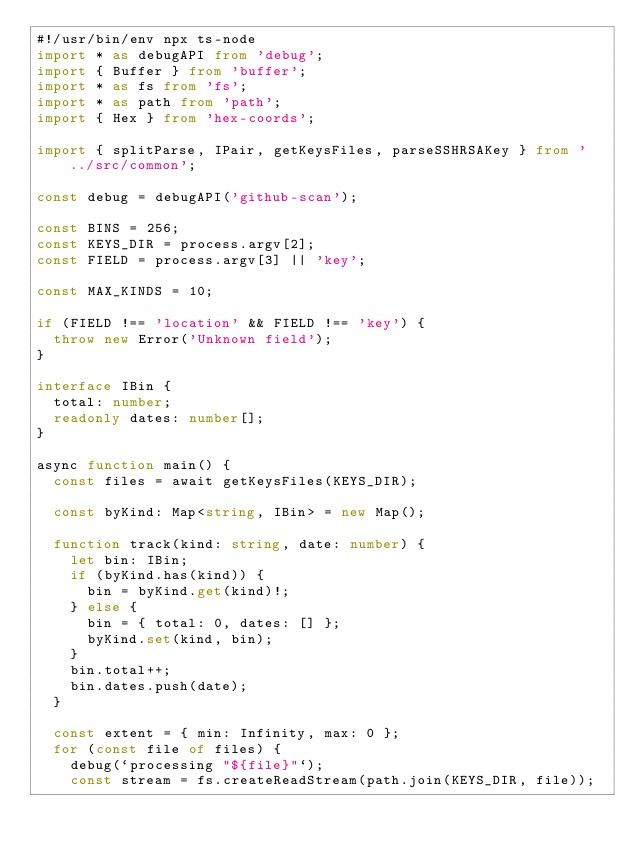Convert code to text. <code><loc_0><loc_0><loc_500><loc_500><_TypeScript_>#!/usr/bin/env npx ts-node
import * as debugAPI from 'debug';
import { Buffer } from 'buffer';
import * as fs from 'fs';
import * as path from 'path';
import { Hex } from 'hex-coords';

import { splitParse, IPair, getKeysFiles, parseSSHRSAKey } from '../src/common';

const debug = debugAPI('github-scan');

const BINS = 256;
const KEYS_DIR = process.argv[2];
const FIELD = process.argv[3] || 'key';

const MAX_KINDS = 10;

if (FIELD !== 'location' && FIELD !== 'key') {
  throw new Error('Unknown field');
}

interface IBin {
  total: number;
  readonly dates: number[];
}

async function main() {
  const files = await getKeysFiles(KEYS_DIR);

  const byKind: Map<string, IBin> = new Map();

  function track(kind: string, date: number) {
    let bin: IBin;
    if (byKind.has(kind)) {
      bin = byKind.get(kind)!;
    } else {
      bin = { total: 0, dates: [] };
      byKind.set(kind, bin);
    }
    bin.total++;
    bin.dates.push(date);
  }

  const extent = { min: Infinity, max: 0 };
  for (const file of files) {
    debug(`processing "${file}"`);
    const stream = fs.createReadStream(path.join(KEYS_DIR, file));</code> 